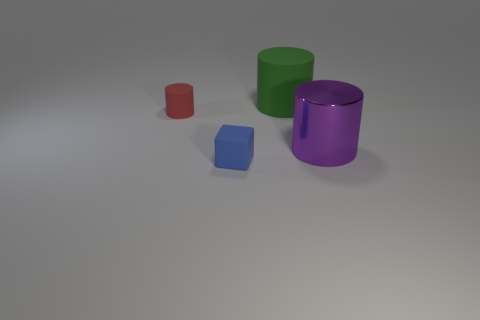Add 4 blue matte things. How many objects exist? 8 Subtract all cubes. How many objects are left? 3 Add 3 large green rubber objects. How many large green rubber objects exist? 4 Subtract 0 green balls. How many objects are left? 4 Subtract all blue blocks. Subtract all red matte cylinders. How many objects are left? 2 Add 1 large rubber cylinders. How many large rubber cylinders are left? 2 